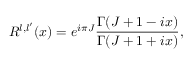<formula> <loc_0><loc_0><loc_500><loc_500>R ^ { l , l ^ { \prime } } ( x ) = e ^ { i \pi J } \frac { \Gamma ( J + 1 - i x ) } { \Gamma ( J + 1 + i x ) } ,</formula> 